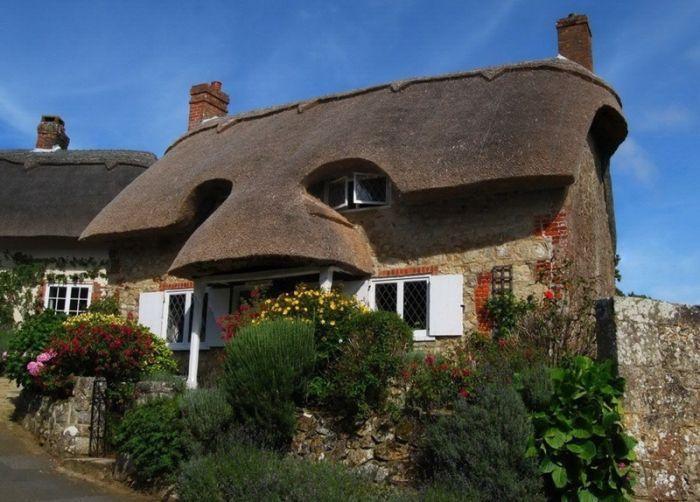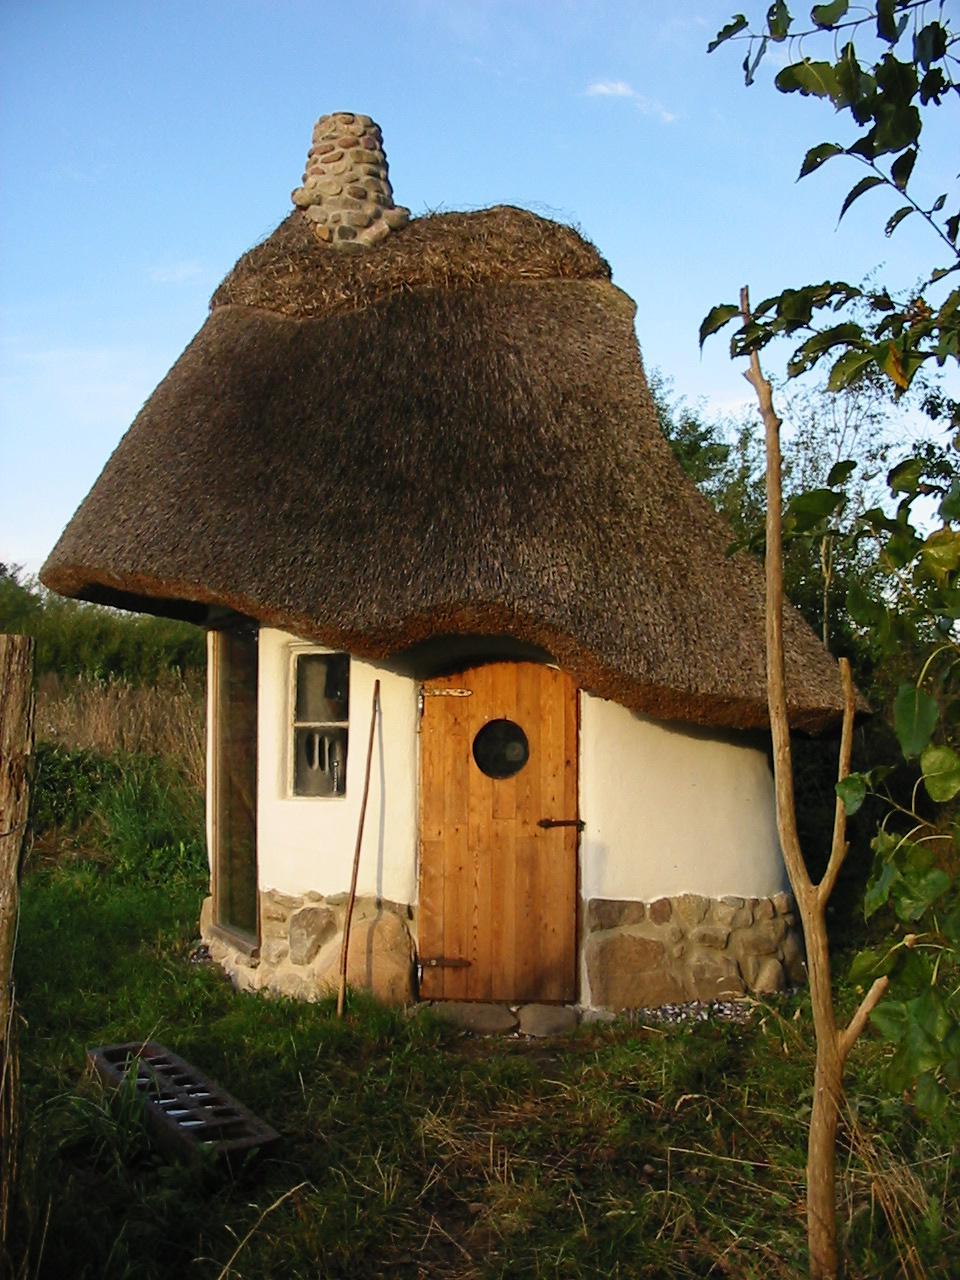The first image is the image on the left, the second image is the image on the right. Evaluate the accuracy of this statement regarding the images: "In each image, a building has a gray roof that curves around items like windows or doors instead of just overhanging them.". Is it true? Answer yes or no. Yes. The first image is the image on the left, the second image is the image on the right. Examine the images to the left and right. Is the description "A short stone wall bounds the house in the image on the left." accurate? Answer yes or no. Yes. 